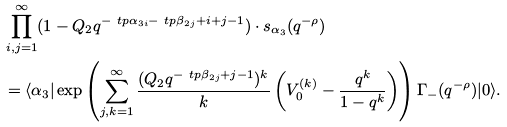<formula> <loc_0><loc_0><loc_500><loc_500>& \prod _ { i , j = 1 } ^ { \infty } ( 1 - Q _ { 2 } q ^ { - \ t p { \alpha } _ { 3 i } - \ t p { \beta } _ { 2 j } + i + j - 1 } ) \cdot s _ { \alpha _ { 3 } } ( q ^ { - \rho } ) \\ & = \langle \alpha _ { 3 } | \exp \left ( \sum _ { j , k = 1 } ^ { \infty } \frac { ( Q _ { 2 } q ^ { - \ t p { \beta } _ { 2 j } + j - 1 } ) ^ { k } } { k } \left ( V ^ { ( k ) } _ { 0 } - \frac { q ^ { k } } { 1 - q ^ { k } } \right ) \right ) \Gamma _ { - } ( q ^ { - \rho } ) | 0 \rangle .</formula> 